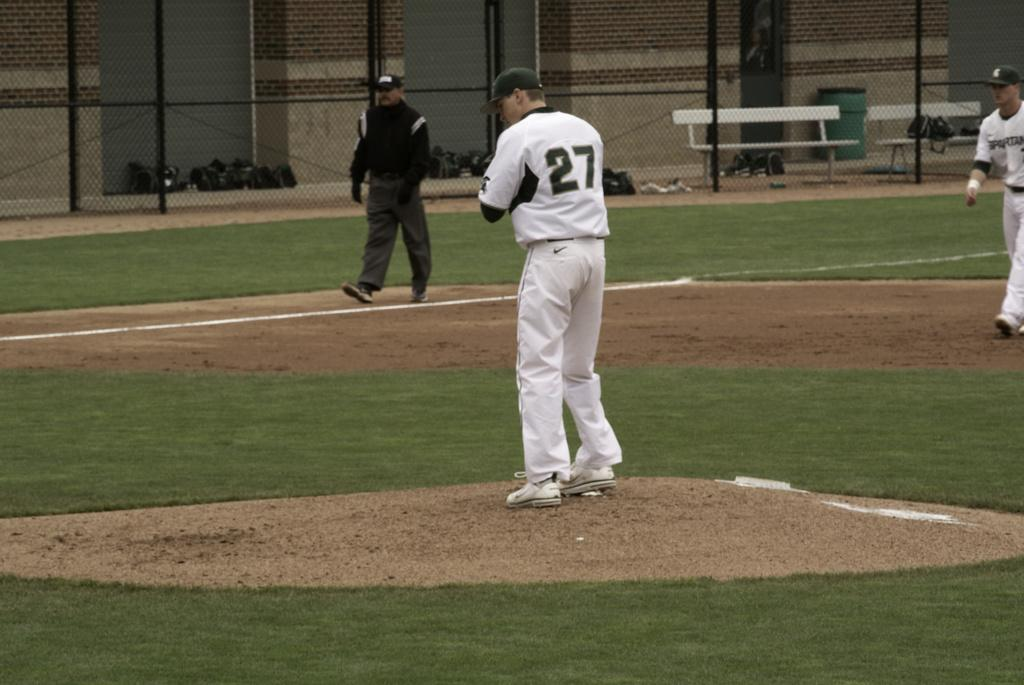Who or what can be seen in the image? There are people in the image. What type of surface is underfoot in the image? There is grass on the ground. What structures can be seen in the background of the image? There are poles, benches, a mesh, bags, and brick walls in the background. What type of medical advice is the doctor giving in the image? There is no doctor present in the image, so no medical advice can be given. What type of glove is being used in the image? There is no glove present in the image. 